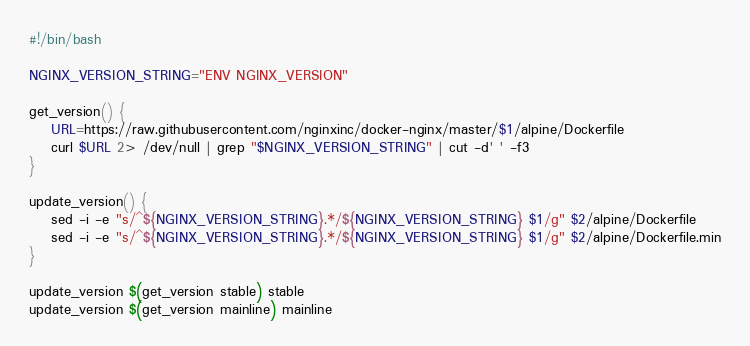<code> <loc_0><loc_0><loc_500><loc_500><_Bash_>#!/bin/bash

NGINX_VERSION_STRING="ENV NGINX_VERSION"

get_version() {
    URL=https://raw.githubusercontent.com/nginxinc/docker-nginx/master/$1/alpine/Dockerfile
    curl $URL 2> /dev/null | grep "$NGINX_VERSION_STRING" | cut -d' ' -f3
}

update_version() {
    sed -i -e "s/^${NGINX_VERSION_STRING}.*/${NGINX_VERSION_STRING} $1/g" $2/alpine/Dockerfile
    sed -i -e "s/^${NGINX_VERSION_STRING}.*/${NGINX_VERSION_STRING} $1/g" $2/alpine/Dockerfile.min
}

update_version $(get_version stable) stable
update_version $(get_version mainline) mainline
</code> 